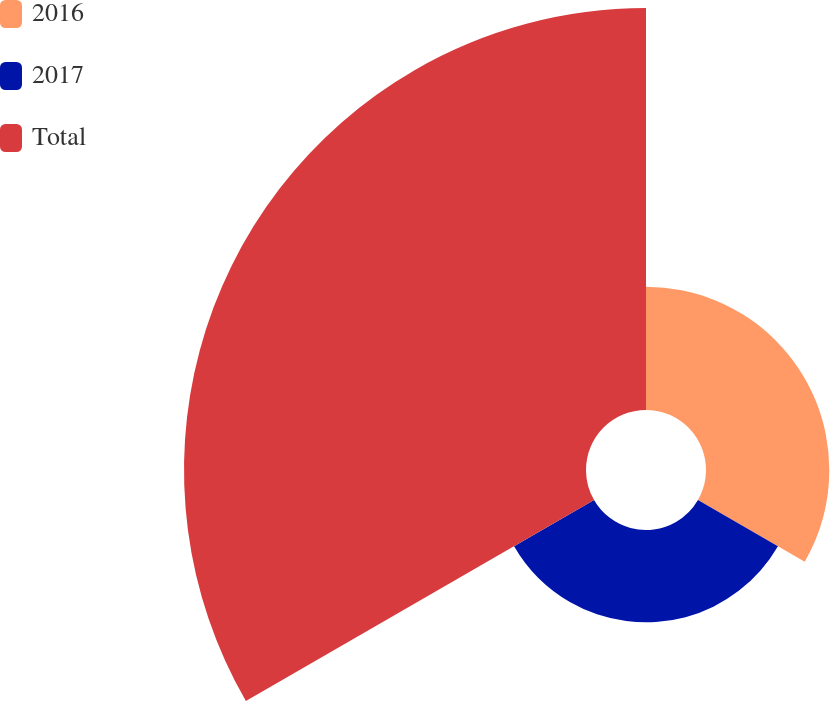<chart> <loc_0><loc_0><loc_500><loc_500><pie_chart><fcel>2016<fcel>2017<fcel>Total<nl><fcel>19.96%<fcel>14.95%<fcel>65.08%<nl></chart> 